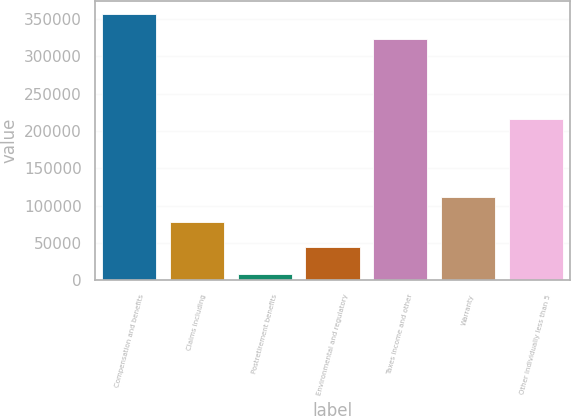Convert chart to OTSL. <chart><loc_0><loc_0><loc_500><loc_500><bar_chart><fcel>Compensation and benefits<fcel>Claims including<fcel>Postretirement benefits<fcel>Environmental and regulatory<fcel>Taxes income and other<fcel>Warranty<fcel>Other individually less than 5<nl><fcel>356754<fcel>78411.9<fcel>8000<fcel>44915<fcel>323257<fcel>111909<fcel>215939<nl></chart> 